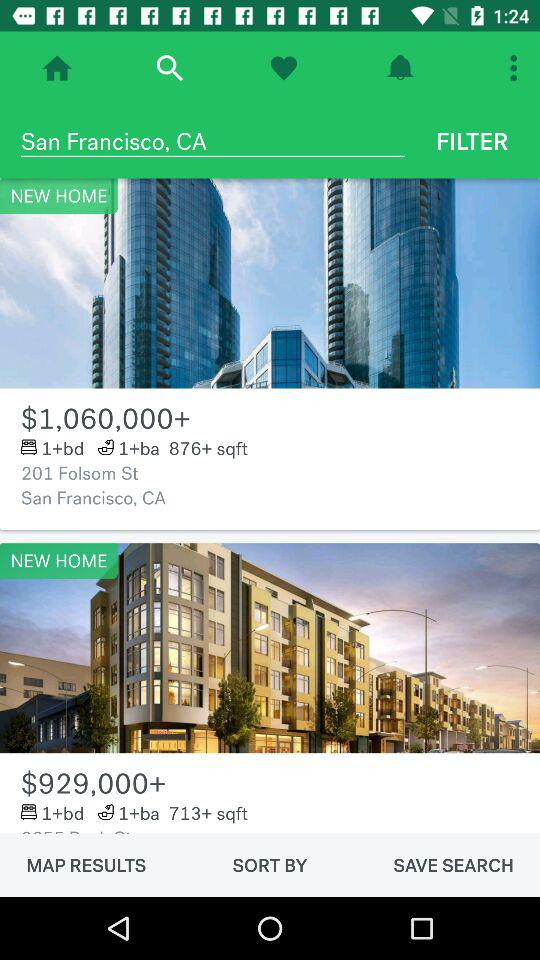How much more expensive is the first home than the second?
Answer the question using a single word or phrase. $131,000 